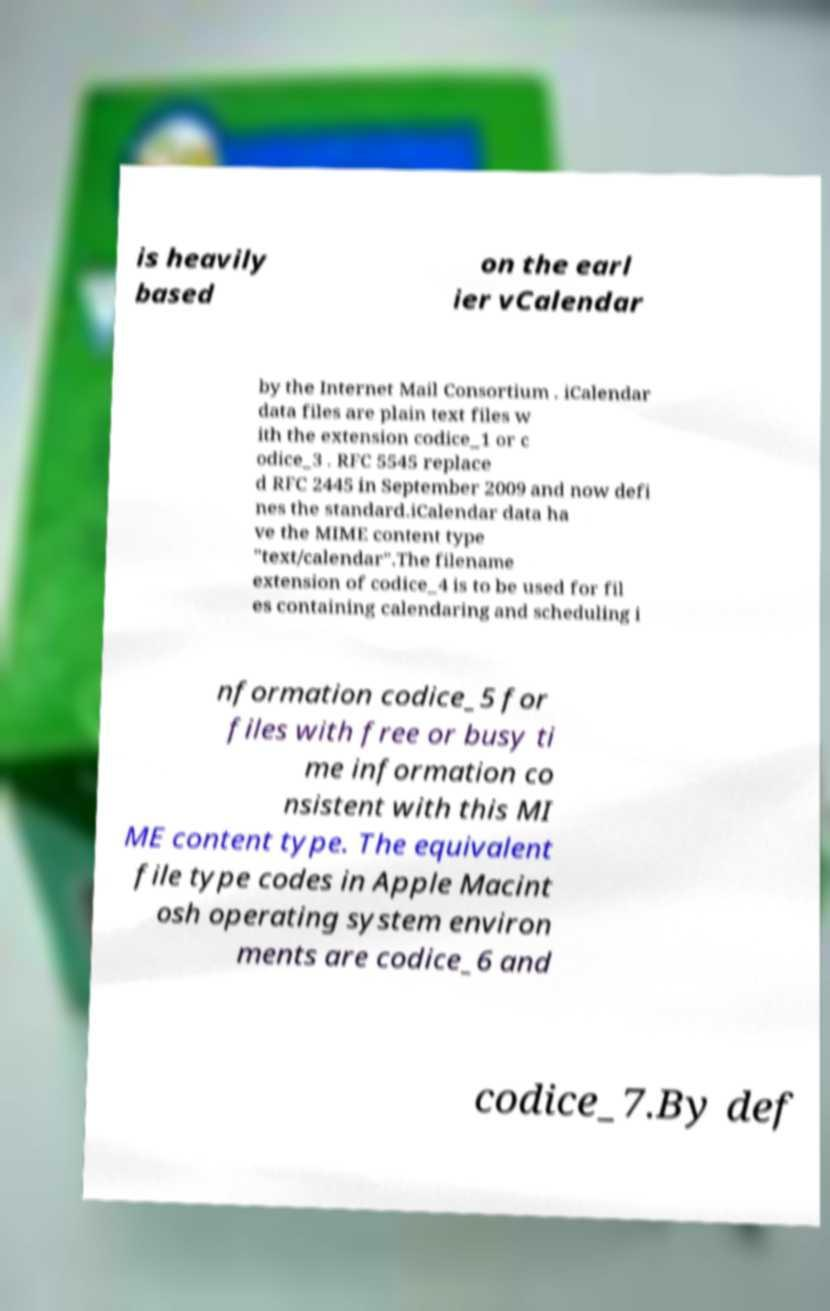Can you read and provide the text displayed in the image?This photo seems to have some interesting text. Can you extract and type it out for me? is heavily based on the earl ier vCalendar by the Internet Mail Consortium . iCalendar data files are plain text files w ith the extension codice_1 or c odice_3 . RFC 5545 replace d RFC 2445 in September 2009 and now defi nes the standard.iCalendar data ha ve the MIME content type "text/calendar".The filename extension of codice_4 is to be used for fil es containing calendaring and scheduling i nformation codice_5 for files with free or busy ti me information co nsistent with this MI ME content type. The equivalent file type codes in Apple Macint osh operating system environ ments are codice_6 and codice_7.By def 